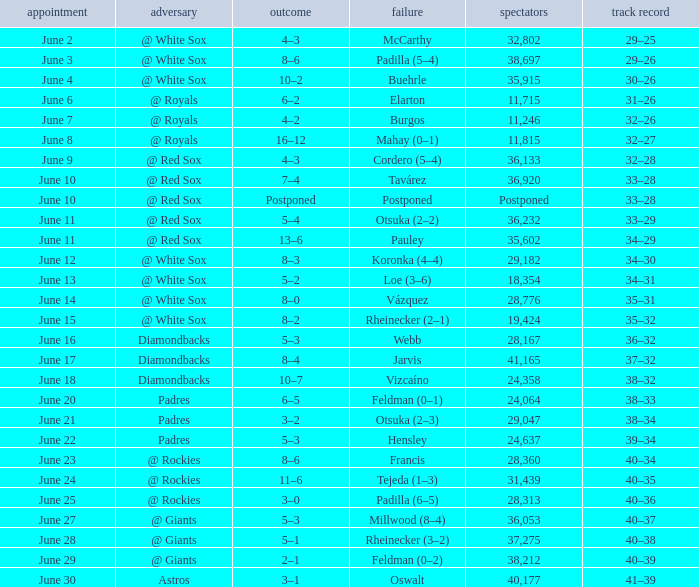When did tavárez lose? June 10. 